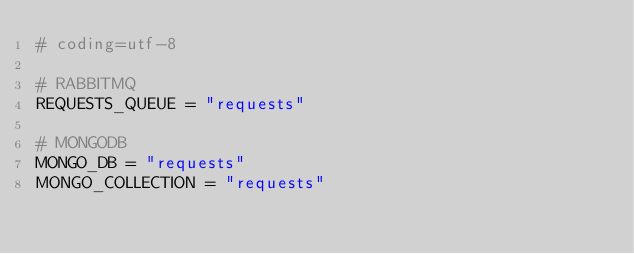<code> <loc_0><loc_0><loc_500><loc_500><_Python_># coding=utf-8

# RABBITMQ
REQUESTS_QUEUE = "requests"

# MONGODB
MONGO_DB = "requests"
MONGO_COLLECTION = "requests"
</code> 